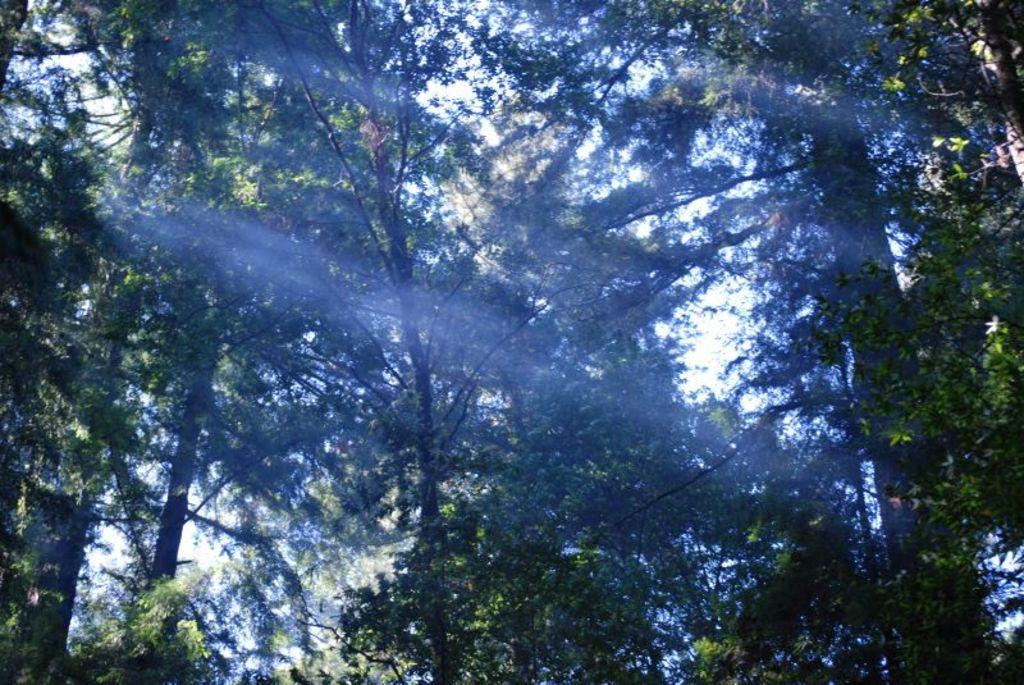How would you summarize this image in a sentence or two? In the center of the image there are many trees. 